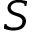Convert formula to latex. <formula><loc_0><loc_0><loc_500><loc_500>S</formula> 